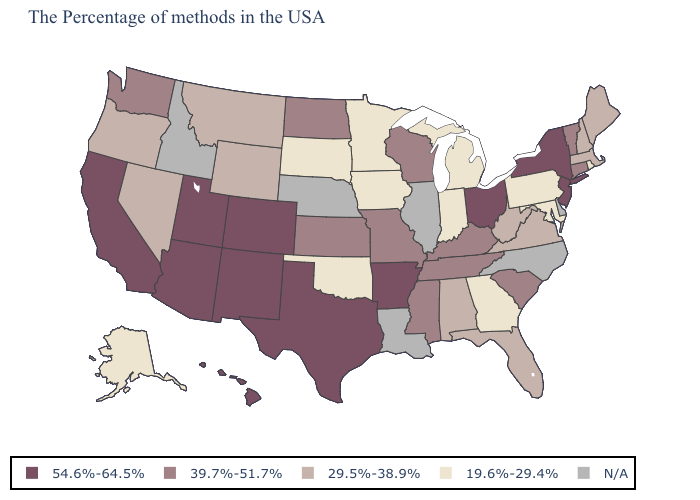Name the states that have a value in the range 19.6%-29.4%?
Quick response, please. Rhode Island, Maryland, Pennsylvania, Georgia, Michigan, Indiana, Minnesota, Iowa, Oklahoma, South Dakota, Alaska. Does New Mexico have the highest value in the USA?
Quick response, please. Yes. Which states have the highest value in the USA?
Short answer required. New York, New Jersey, Ohio, Arkansas, Texas, Colorado, New Mexico, Utah, Arizona, California, Hawaii. What is the value of Maine?
Keep it brief. 29.5%-38.9%. What is the value of South Carolina?
Short answer required. 39.7%-51.7%. Does the map have missing data?
Short answer required. Yes. What is the lowest value in states that border Missouri?
Keep it brief. 19.6%-29.4%. Name the states that have a value in the range 29.5%-38.9%?
Short answer required. Maine, Massachusetts, New Hampshire, Virginia, West Virginia, Florida, Alabama, Wyoming, Montana, Nevada, Oregon. Name the states that have a value in the range 39.7%-51.7%?
Write a very short answer. Vermont, Connecticut, South Carolina, Kentucky, Tennessee, Wisconsin, Mississippi, Missouri, Kansas, North Dakota, Washington. Name the states that have a value in the range 29.5%-38.9%?
Write a very short answer. Maine, Massachusetts, New Hampshire, Virginia, West Virginia, Florida, Alabama, Wyoming, Montana, Nevada, Oregon. Which states have the lowest value in the Northeast?
Keep it brief. Rhode Island, Pennsylvania. Does the first symbol in the legend represent the smallest category?
Keep it brief. No. What is the lowest value in the South?
Write a very short answer. 19.6%-29.4%. What is the value of Maryland?
Answer briefly. 19.6%-29.4%. 